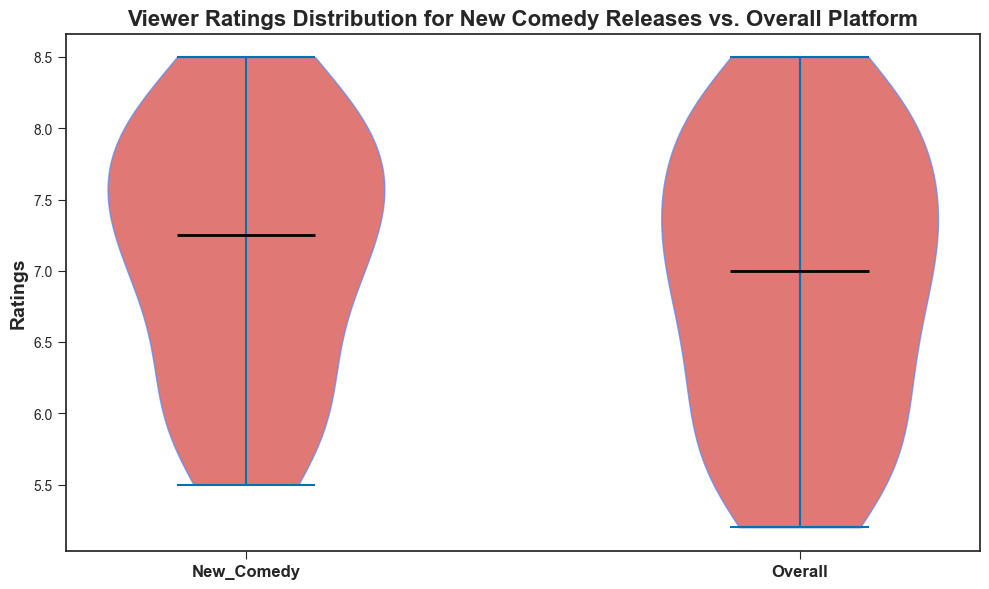What's the median rating for New Comedy releases? To determine the median, look at the violin plot's horizontal line in the middle of the New Comedy section.
Answer: 7.3 Which category has a wider range of ratings? Analyze the spread of the two violin plots. The wider the plot, the broader the range of ratings.
Answer: Overall Are the median ratings for New Comedy higher or lower than the Overall median ratings? Compare the position of the black horizontal lines (medians) in the New Comedy and Overall plots. The New Comedy median appears higher.
Answer: Higher What's the highest rating recorded on the platform overall? Identify the topmost point of the Overall violin plot.
Answer: 8.5 Do New Comedy releases have any ratings that fall below the platform's median rating? Check if any part of the New Comedy plot falls below the Overall median (shown by a horizontal line). Parts of the New Comedy plot dip below the Overall median.
Answer: Yes What is the most common rating range for New Comedy releases? Look at the thickest part of the New Comedy plot, indicating the highest density of ratings.
Answer: Approximately 6.8 to 8.1 How does the interquartile range (IQR) of New Comedy releases compare to the Overall IQR? Note the spread of the middle 50% of values, shown by the widest parts of both plots. The IQR for Overall is slightly larger indicating a broader distribution compared to New Comedy.
Answer: Overall IQR is larger Does the Overall category have any rating values that are outliers or seem rare? Observe if there are any narrow ends or tails in the Overall plot that indicate infrequent ratings. There are thin tails at the highest and lowest points.
Answer: Yes What color represents the area within the violin plots, and what does it signify? The area within the violin plots is a specific color, which in this case is red, representing the density or frequency of ratings at different levels.
Answer: Red, represents rating densities 